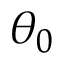Convert formula to latex. <formula><loc_0><loc_0><loc_500><loc_500>\theta _ { 0 }</formula> 